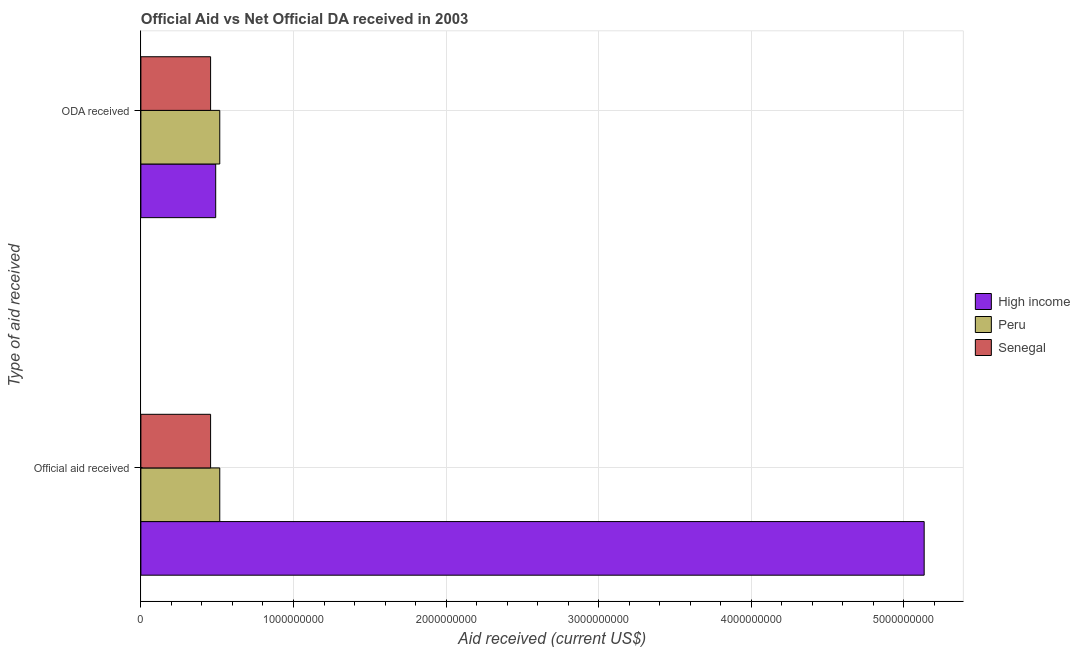Are the number of bars per tick equal to the number of legend labels?
Make the answer very short. Yes. How many bars are there on the 1st tick from the top?
Make the answer very short. 3. What is the label of the 1st group of bars from the top?
Keep it short and to the point. ODA received. What is the oda received in High income?
Make the answer very short. 4.90e+08. Across all countries, what is the maximum official aid received?
Offer a very short reply. 5.13e+09. Across all countries, what is the minimum official aid received?
Give a very brief answer. 4.57e+08. In which country was the official aid received minimum?
Keep it short and to the point. Senegal. What is the total official aid received in the graph?
Provide a short and direct response. 6.11e+09. What is the difference between the oda received in High income and that in Senegal?
Keep it short and to the point. 3.34e+07. What is the difference between the official aid received in High income and the oda received in Peru?
Your response must be concise. 4.62e+09. What is the average official aid received per country?
Provide a succinct answer. 2.04e+09. What is the difference between the oda received and official aid received in High income?
Provide a short and direct response. -4.64e+09. In how many countries, is the official aid received greater than 2400000000 US$?
Make the answer very short. 1. What is the ratio of the official aid received in High income to that in Senegal?
Give a very brief answer. 11.24. In how many countries, is the oda received greater than the average oda received taken over all countries?
Provide a succinct answer. 2. What does the 2nd bar from the top in ODA received represents?
Give a very brief answer. Peru. How many countries are there in the graph?
Offer a terse response. 3. How are the legend labels stacked?
Make the answer very short. Vertical. What is the title of the graph?
Make the answer very short. Official Aid vs Net Official DA received in 2003 . What is the label or title of the X-axis?
Provide a succinct answer. Aid received (current US$). What is the label or title of the Y-axis?
Give a very brief answer. Type of aid received. What is the Aid received (current US$) in High income in Official aid received?
Your answer should be compact. 5.13e+09. What is the Aid received (current US$) in Peru in Official aid received?
Your answer should be compact. 5.17e+08. What is the Aid received (current US$) in Senegal in Official aid received?
Keep it short and to the point. 4.57e+08. What is the Aid received (current US$) in High income in ODA received?
Offer a terse response. 4.90e+08. What is the Aid received (current US$) of Peru in ODA received?
Provide a succinct answer. 5.17e+08. What is the Aid received (current US$) in Senegal in ODA received?
Your response must be concise. 4.57e+08. Across all Type of aid received, what is the maximum Aid received (current US$) of High income?
Provide a succinct answer. 5.13e+09. Across all Type of aid received, what is the maximum Aid received (current US$) of Peru?
Keep it short and to the point. 5.17e+08. Across all Type of aid received, what is the maximum Aid received (current US$) in Senegal?
Make the answer very short. 4.57e+08. Across all Type of aid received, what is the minimum Aid received (current US$) of High income?
Make the answer very short. 4.90e+08. Across all Type of aid received, what is the minimum Aid received (current US$) in Peru?
Give a very brief answer. 5.17e+08. Across all Type of aid received, what is the minimum Aid received (current US$) of Senegal?
Offer a terse response. 4.57e+08. What is the total Aid received (current US$) of High income in the graph?
Provide a succinct answer. 5.62e+09. What is the total Aid received (current US$) in Peru in the graph?
Ensure brevity in your answer.  1.03e+09. What is the total Aid received (current US$) of Senegal in the graph?
Your response must be concise. 9.14e+08. What is the difference between the Aid received (current US$) of High income in Official aid received and that in ODA received?
Your answer should be very brief. 4.64e+09. What is the difference between the Aid received (current US$) in Peru in Official aid received and that in ODA received?
Provide a succinct answer. 0. What is the difference between the Aid received (current US$) of High income in Official aid received and the Aid received (current US$) of Peru in ODA received?
Ensure brevity in your answer.  4.62e+09. What is the difference between the Aid received (current US$) in High income in Official aid received and the Aid received (current US$) in Senegal in ODA received?
Offer a terse response. 4.68e+09. What is the difference between the Aid received (current US$) of Peru in Official aid received and the Aid received (current US$) of Senegal in ODA received?
Your response must be concise. 6.01e+07. What is the average Aid received (current US$) of High income per Type of aid received?
Make the answer very short. 2.81e+09. What is the average Aid received (current US$) in Peru per Type of aid received?
Your answer should be compact. 5.17e+08. What is the average Aid received (current US$) of Senegal per Type of aid received?
Offer a terse response. 4.57e+08. What is the difference between the Aid received (current US$) in High income and Aid received (current US$) in Peru in Official aid received?
Your answer should be very brief. 4.62e+09. What is the difference between the Aid received (current US$) in High income and Aid received (current US$) in Senegal in Official aid received?
Provide a short and direct response. 4.68e+09. What is the difference between the Aid received (current US$) in Peru and Aid received (current US$) in Senegal in Official aid received?
Offer a very short reply. 6.01e+07. What is the difference between the Aid received (current US$) in High income and Aid received (current US$) in Peru in ODA received?
Provide a short and direct response. -2.67e+07. What is the difference between the Aid received (current US$) of High income and Aid received (current US$) of Senegal in ODA received?
Offer a terse response. 3.34e+07. What is the difference between the Aid received (current US$) in Peru and Aid received (current US$) in Senegal in ODA received?
Offer a very short reply. 6.01e+07. What is the ratio of the Aid received (current US$) in High income in Official aid received to that in ODA received?
Keep it short and to the point. 10.47. What is the difference between the highest and the second highest Aid received (current US$) of High income?
Give a very brief answer. 4.64e+09. What is the difference between the highest and the second highest Aid received (current US$) of Peru?
Ensure brevity in your answer.  0. What is the difference between the highest and the lowest Aid received (current US$) of High income?
Keep it short and to the point. 4.64e+09. What is the difference between the highest and the lowest Aid received (current US$) of Peru?
Your answer should be very brief. 0. What is the difference between the highest and the lowest Aid received (current US$) in Senegal?
Provide a succinct answer. 0. 